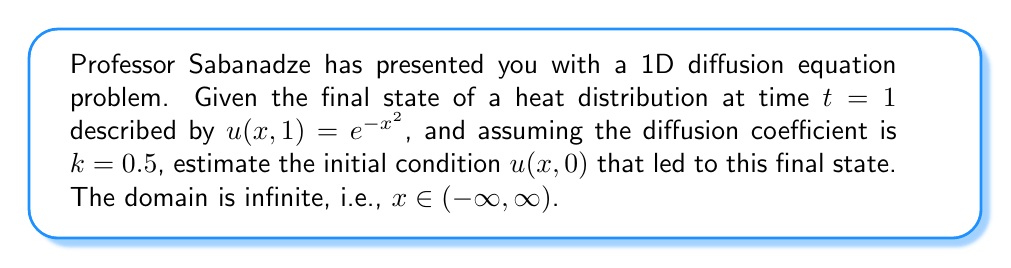Can you answer this question? To solve this inverse problem, we'll follow these steps:

1) The general solution for the 1D diffusion equation is given by:

   $$u(x,t) = \frac{1}{\sqrt{4\pi kt}} \int_{-\infty}^{\infty} u(\xi,0) e^{-\frac{(x-\xi)^2}{4kt}} d\xi$$

2) We're given $u(x,1) = e^{-x^2}$, $k=0.5$, and $t=1$. Substituting these into the general solution:

   $$e^{-x^2} = \frac{1}{\sqrt{2\pi}} \int_{-\infty}^{\infty} u(\xi,0) e^{-\frac{(x-\xi)^2}{2}} d\xi$$

3) This equation suggests that $u(\xi,0)$ is the inverse Fourier transform of $e^{-x^2}$.

4) The Fourier transform of a Gaussian function is another Gaussian:

   $$\mathcal{F}\{e^{-ax^2}\} = \sqrt{\frac{\pi}{a}}e^{-\frac{\omega^2}{4a}}$$

5) In our case, $a=1$, so the Fourier transform of $e^{-x^2}$ is $\sqrt{\pi}e^{-\frac{\omega^2}{4}}$.

6) To get the inverse Fourier transform, we need to scale this by $\frac{1}{\sqrt{2\pi}}$:

   $$u(\xi,0) = \frac{1}{\sqrt{2\pi}} \cdot \sqrt{\pi}e^{-\frac{\xi^2}{4}} = \frac{1}{\sqrt{2}}e^{-\frac{\xi^2}{4}}$$

7) Therefore, the estimated initial condition is:

   $$u(x,0) = \frac{1}{\sqrt{2}}e^{-\frac{x^2}{4}}$$
Answer: $u(x,0) = \frac{1}{\sqrt{2}}e^{-\frac{x^2}{4}}$ 